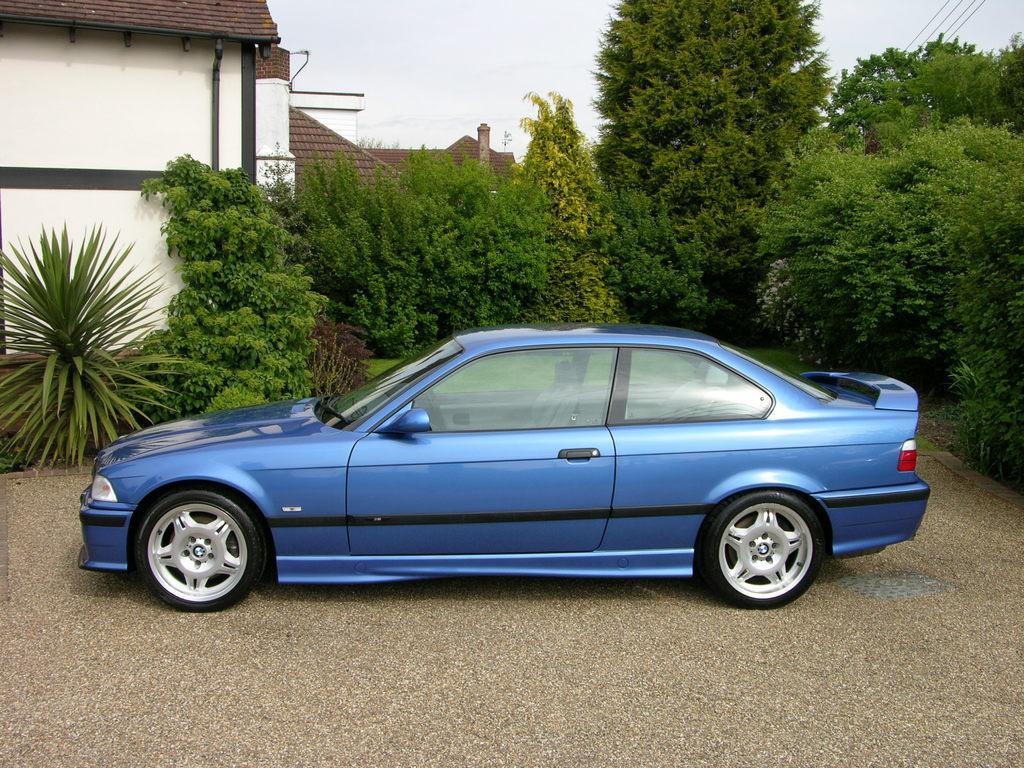How would you summarize this image in a sentence or two? In the picture I can see a blue color car on the ground. In the background I can see trees, plants, wires, the sky, houses and some other objects. 